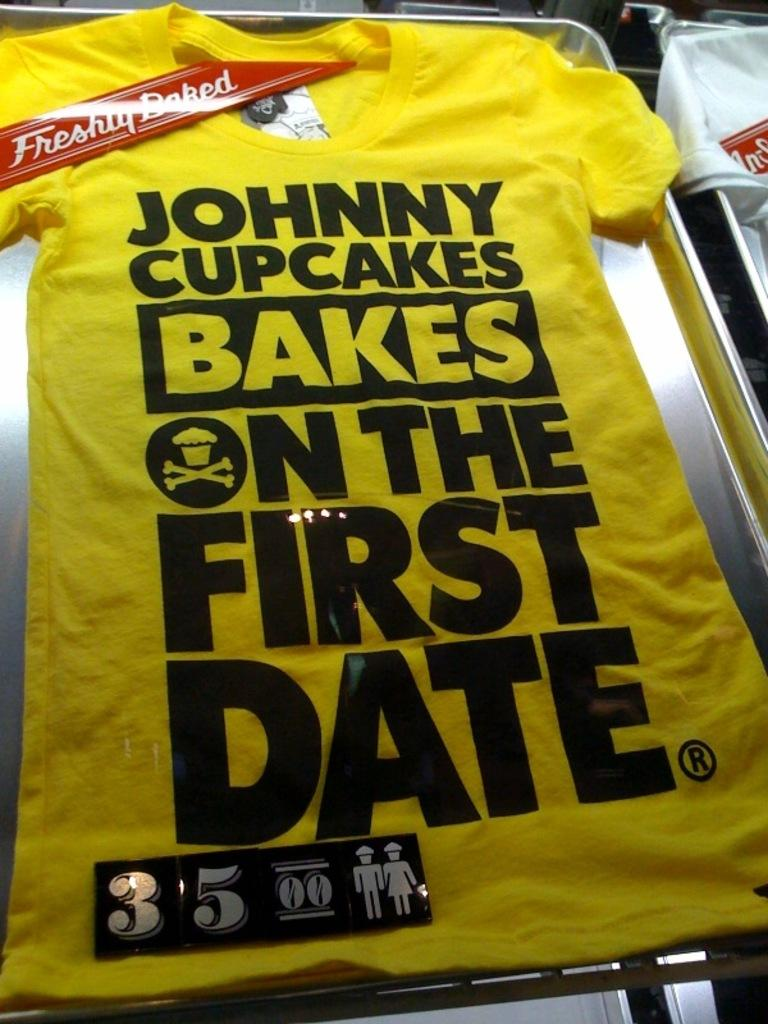<image>
Give a short and clear explanation of the subsequent image. Yellow shirt that says "Johnny cupcakes bakes on the first date" 